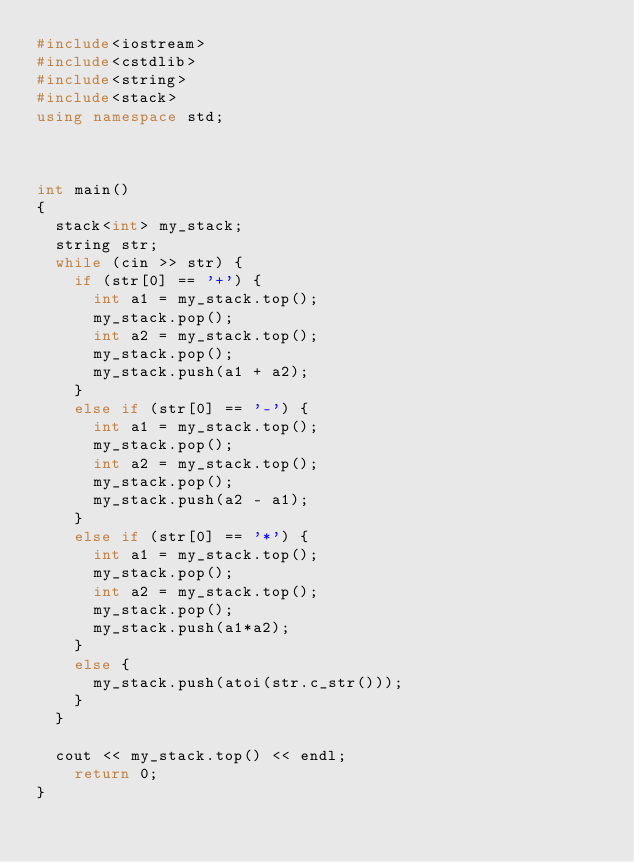<code> <loc_0><loc_0><loc_500><loc_500><_C++_>#include<iostream>
#include<cstdlib>
#include<string>
#include<stack>
using namespace std;



int main()
{
	stack<int> my_stack;
	string str;
	while (cin >> str) {
		if (str[0] == '+') {
			int a1 = my_stack.top();
			my_stack.pop();
			int a2 = my_stack.top();
			my_stack.pop();
			my_stack.push(a1 + a2);
		}
		else if (str[0] == '-') {
			int a1 = my_stack.top();
			my_stack.pop();
			int a2 = my_stack.top();
			my_stack.pop();
			my_stack.push(a2 - a1);
		}
		else if (str[0] == '*') {
			int a1 = my_stack.top();
			my_stack.pop();
			int a2 = my_stack.top();
			my_stack.pop();
			my_stack.push(a1*a2);
		}
		else {
			my_stack.push(atoi(str.c_str()));
		}
	}

	cout << my_stack.top() << endl;
    return 0;
}
</code> 